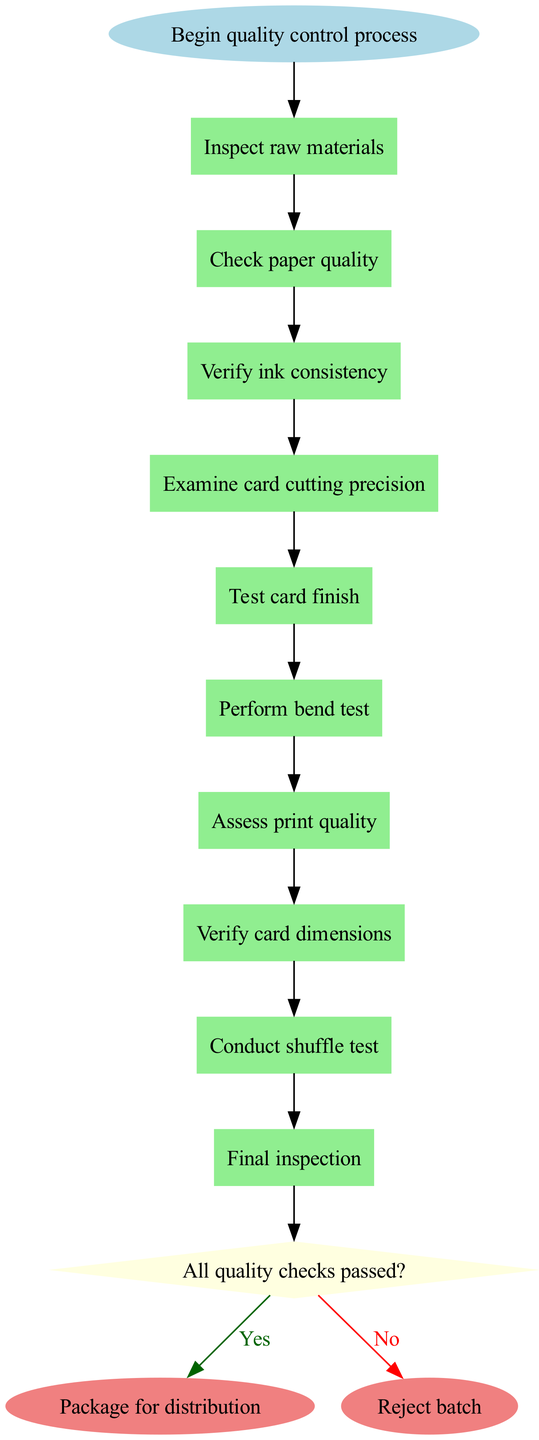What is the first step in the quality control process? The first step listed in the diagram is "Inspect raw materials," which appears directly after the starting point in the flowchart.
Answer: Inspect raw materials How many steps are there in the quality control process? By counting the individual steps listed in the diagram, there are a total of 9 process steps leading to the decision node.
Answer: 9 What happens after examining card cutting precision? Following the step "Examine card cutting precision," the next step indicated in the diagram is "Test card finish." This relationship shows the direct flow from one step to the next.
Answer: Test card finish What does the decision node ask? The decision node presents the condition "All quality checks passed?" which determines the next direction of the flowchart based on the outcomes of the previous steps.
Answer: All quality checks passed? What is the final outcome if all quality checks pass? The final outcome indicated for a "Yes" answer at the decision node is "Package for distribution," which represents the process's completion if everything is satisfactory.
Answer: Package for distribution What is the last process step before the decision? The last process step before reaching the decision node is "Conduct shuffle test," which is the final step in the quality control checks leading up to the evaluation.
Answer: Conduct shuffle test Which step follows the assess print quality? The step that follows "Assess print quality" in the flowchart is "Verify card dimensions," indicating the sequential nature of the quality control checks.
Answer: Verify card dimensions What color represents the decision node in the flowchart? The decision node is colored light yellow as specified in the diagram's attributes, distinguishing it visually from other types of nodes present.
Answer: Light yellow What action is taken if the decision is "No"? If the decision is "No," as indicated in the flowchart, the resulting action is to "Reject batch," highlighting a negative outcome in the quality control process.
Answer: Reject batch 